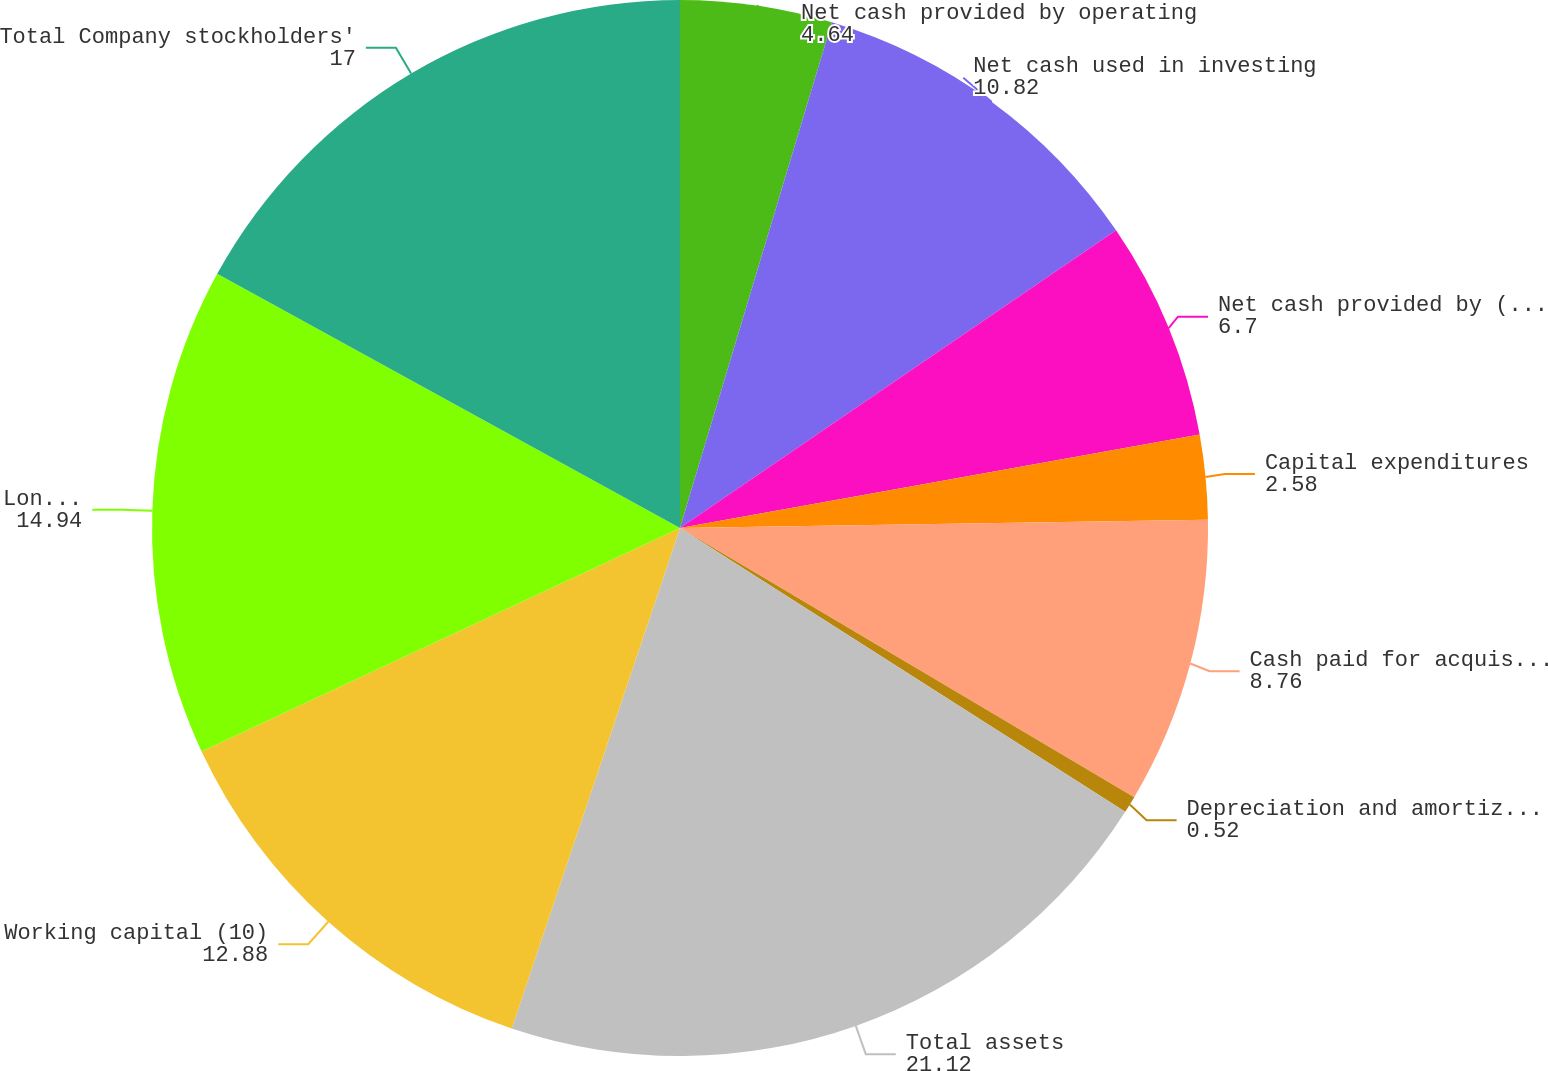<chart> <loc_0><loc_0><loc_500><loc_500><pie_chart><fcel>Net cash provided by operating<fcel>Net cash used in investing<fcel>Net cash provided by (used in)<fcel>Capital expenditures<fcel>Cash paid for acquisitions net<fcel>Depreciation and amortization<fcel>Total assets<fcel>Working capital (10)<fcel>Long-term obligations<fcel>Total Company stockholders'<nl><fcel>4.64%<fcel>10.82%<fcel>6.7%<fcel>2.58%<fcel>8.76%<fcel>0.52%<fcel>21.12%<fcel>12.88%<fcel>14.94%<fcel>17.0%<nl></chart> 